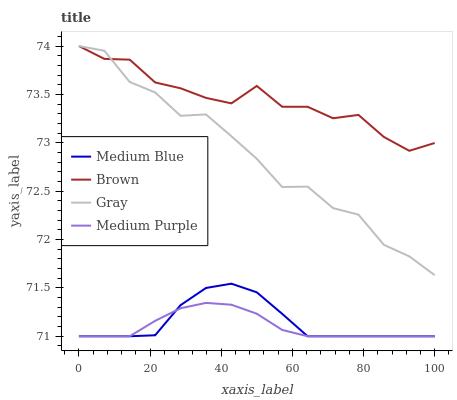Does Medium Purple have the minimum area under the curve?
Answer yes or no. Yes. Does Brown have the maximum area under the curve?
Answer yes or no. Yes. Does Medium Blue have the minimum area under the curve?
Answer yes or no. No. Does Medium Blue have the maximum area under the curve?
Answer yes or no. No. Is Medium Purple the smoothest?
Answer yes or no. Yes. Is Gray the roughest?
Answer yes or no. Yes. Is Brown the smoothest?
Answer yes or no. No. Is Brown the roughest?
Answer yes or no. No. Does Medium Purple have the lowest value?
Answer yes or no. Yes. Does Brown have the lowest value?
Answer yes or no. No. Does Gray have the highest value?
Answer yes or no. Yes. Does Medium Blue have the highest value?
Answer yes or no. No. Is Medium Blue less than Brown?
Answer yes or no. Yes. Is Gray greater than Medium Purple?
Answer yes or no. Yes. Does Medium Blue intersect Medium Purple?
Answer yes or no. Yes. Is Medium Blue less than Medium Purple?
Answer yes or no. No. Is Medium Blue greater than Medium Purple?
Answer yes or no. No. Does Medium Blue intersect Brown?
Answer yes or no. No. 